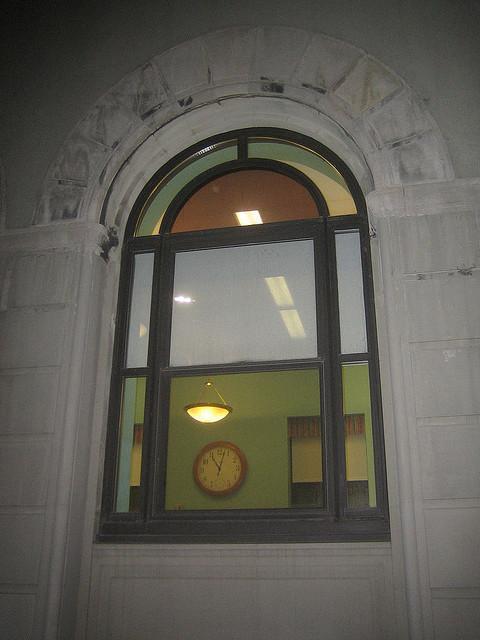How many windows are shown?
Give a very brief answer. 1. 